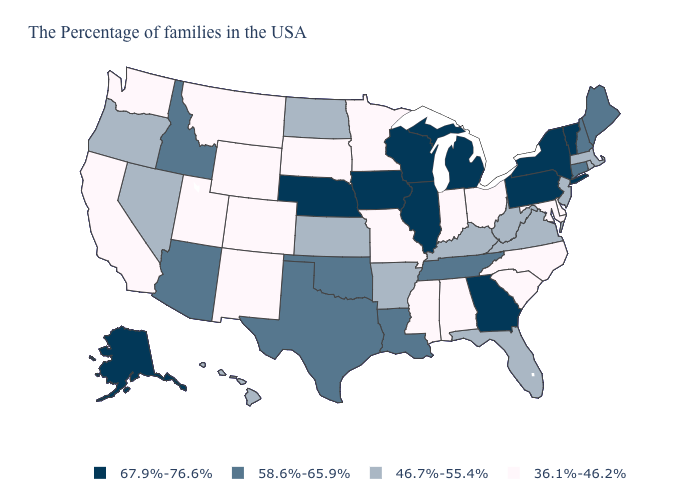Name the states that have a value in the range 46.7%-55.4%?
Write a very short answer. Massachusetts, Rhode Island, New Jersey, Virginia, West Virginia, Florida, Kentucky, Arkansas, Kansas, North Dakota, Nevada, Oregon, Hawaii. What is the lowest value in the USA?
Give a very brief answer. 36.1%-46.2%. What is the value of New Hampshire?
Quick response, please. 58.6%-65.9%. Does Idaho have a lower value than Illinois?
Keep it brief. Yes. What is the highest value in the USA?
Answer briefly. 67.9%-76.6%. What is the lowest value in states that border Pennsylvania?
Be succinct. 36.1%-46.2%. Does Utah have a higher value than Nebraska?
Short answer required. No. Does the map have missing data?
Short answer required. No. Name the states that have a value in the range 36.1%-46.2%?
Answer briefly. Delaware, Maryland, North Carolina, South Carolina, Ohio, Indiana, Alabama, Mississippi, Missouri, Minnesota, South Dakota, Wyoming, Colorado, New Mexico, Utah, Montana, California, Washington. Name the states that have a value in the range 46.7%-55.4%?
Quick response, please. Massachusetts, Rhode Island, New Jersey, Virginia, West Virginia, Florida, Kentucky, Arkansas, Kansas, North Dakota, Nevada, Oregon, Hawaii. Which states hav the highest value in the Northeast?
Answer briefly. Vermont, New York, Pennsylvania. Name the states that have a value in the range 36.1%-46.2%?
Short answer required. Delaware, Maryland, North Carolina, South Carolina, Ohio, Indiana, Alabama, Mississippi, Missouri, Minnesota, South Dakota, Wyoming, Colorado, New Mexico, Utah, Montana, California, Washington. Among the states that border California , which have the lowest value?
Be succinct. Nevada, Oregon. 